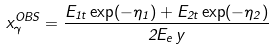<formula> <loc_0><loc_0><loc_500><loc_500>x ^ { O B S } _ { \gamma } = \frac { E _ { 1 t } \exp ( - \eta _ { 1 } ) + E _ { 2 t } \exp ( - \eta _ { 2 } ) } { 2 E _ { e } \, y }</formula> 